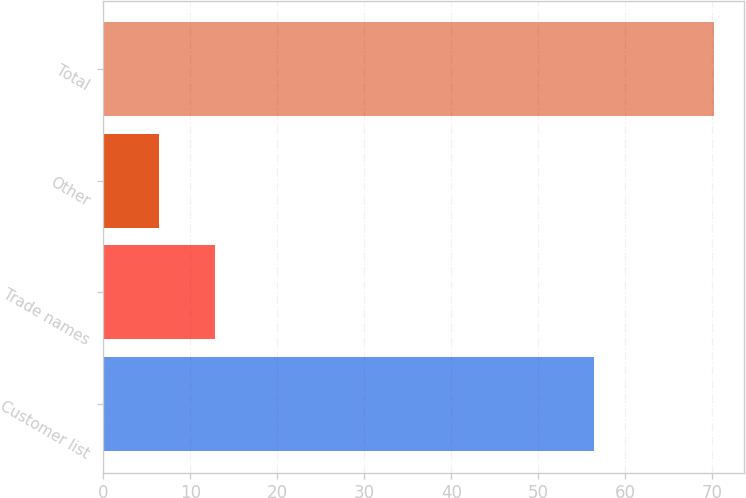Convert chart. <chart><loc_0><loc_0><loc_500><loc_500><bar_chart><fcel>Customer list<fcel>Trade names<fcel>Other<fcel>Total<nl><fcel>56.4<fcel>12.78<fcel>6.4<fcel>70.2<nl></chart> 